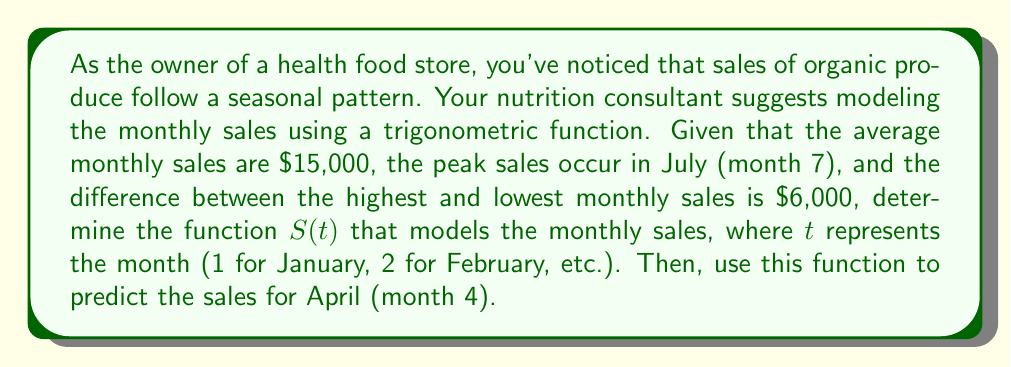What is the answer to this math problem? To model the seasonal sales trend, we'll use a cosine function of the form:

$$S(t) = A \cos(B(t-C)) + D$$

Where:
$A$ is the amplitude (half the difference between max and min sales)
$B$ is the frequency (related to the period)
$C$ is the phase shift (to align the peak with July)
$D$ is the vertical shift (average sales)

Step 1: Determine the parameters
$A = \frac{6000}{2} = 3000$ (amplitude)
$D = 15000$ (vertical shift, average sales)

The period is 12 months, so $B = \frac{2\pi}{12} = \frac{\pi}{6}$

To have the peak in July (month 7), we need $C = 7$

Step 2: Write the function
$$S(t) = 3000 \cos(\frac{\pi}{6}(t-7)) + 15000$$

Step 3: Predict sales for April (t = 4)
$$S(4) = 3000 \cos(\frac{\pi}{6}(4-7)) + 15000$$
$$= 3000 \cos(-\frac{\pi}{2}) + 15000$$
$$= 3000 \cdot 0 + 15000$$
$$= 15000$$

Therefore, the predicted sales for April are $15,000.
Answer: The sales function is $S(t) = 3000 \cos(\frac{\pi}{6}(t-7)) + 15000$, and the predicted sales for April are $15,000. 